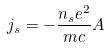<formula> <loc_0><loc_0><loc_500><loc_500>j _ { s } = - \frac { n _ { s } e ^ { 2 } } { m c } A</formula> 